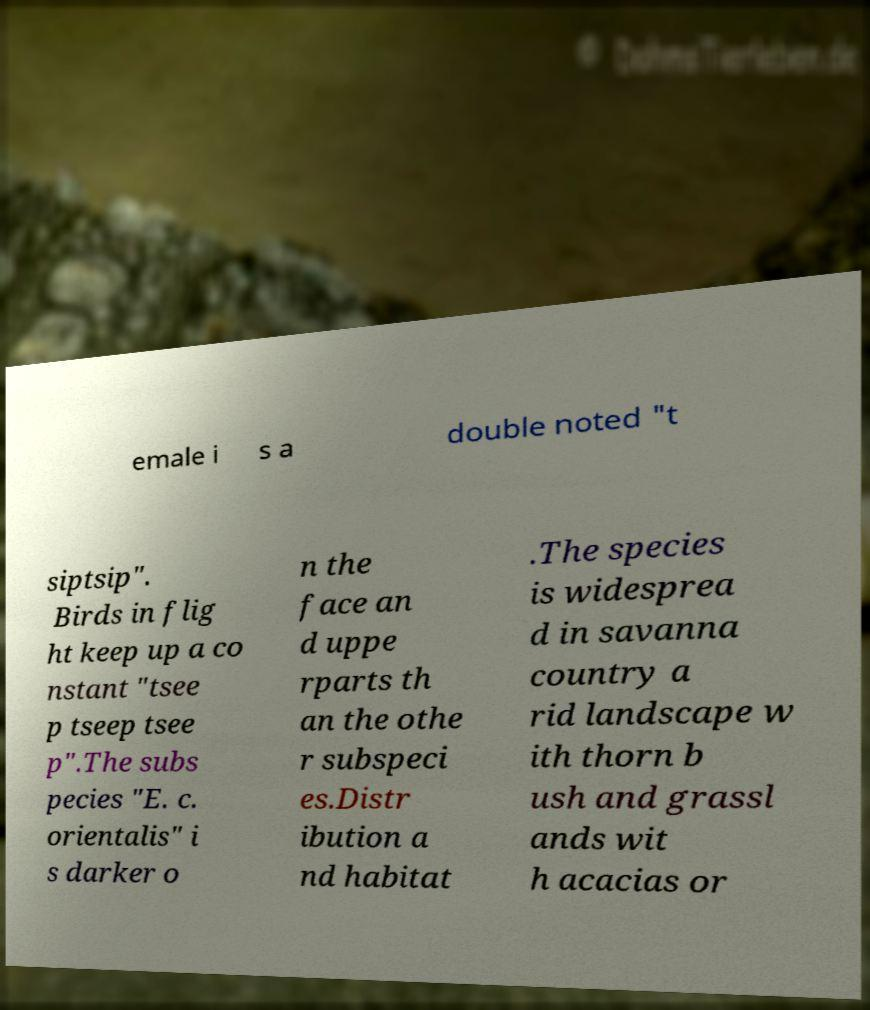Could you assist in decoding the text presented in this image and type it out clearly? emale i s a double noted "t siptsip". Birds in flig ht keep up a co nstant "tsee p tseep tsee p".The subs pecies "E. c. orientalis" i s darker o n the face an d uppe rparts th an the othe r subspeci es.Distr ibution a nd habitat .The species is widesprea d in savanna country a rid landscape w ith thorn b ush and grassl ands wit h acacias or 